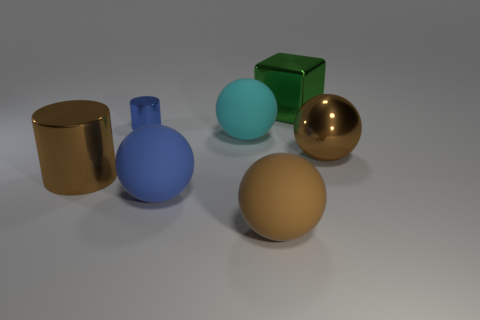There is a brown shiny object that is on the right side of the cyan matte object; does it have the same size as the small metal thing?
Give a very brief answer. No. How many blue things are either large shiny cubes or large rubber spheres?
Provide a succinct answer. 1. There is a big brown object on the left side of the cyan object; what material is it?
Offer a very short reply. Metal. There is a blue cylinder behind the cyan matte ball; how many big things are in front of it?
Ensure brevity in your answer.  5. How many big blue things are the same shape as the brown matte thing?
Your answer should be compact. 1. How many large objects are there?
Your answer should be compact. 6. What is the color of the matte object that is behind the big blue matte ball?
Keep it short and to the point. Cyan. What color is the big rubber object behind the brown ball behind the brown matte object?
Your answer should be very brief. Cyan. What color is the cylinder that is the same size as the brown matte thing?
Offer a terse response. Brown. What number of brown objects are both right of the green object and in front of the large shiny sphere?
Make the answer very short. 0. 